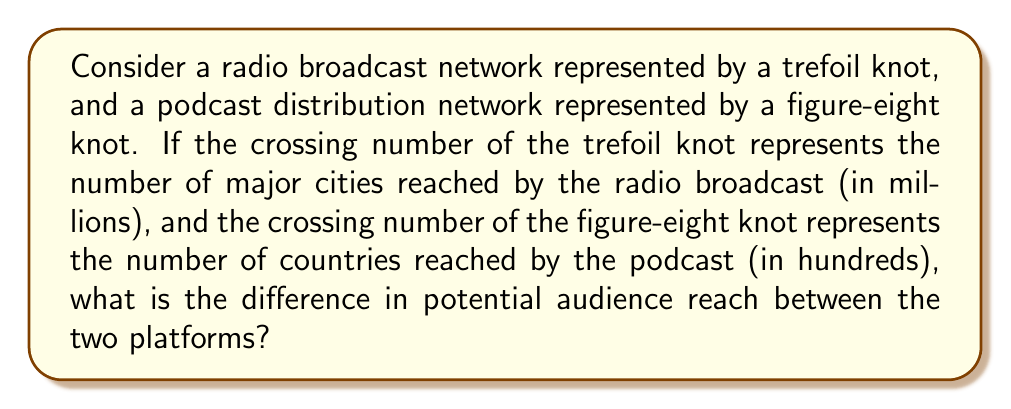Teach me how to tackle this problem. To solve this problem, we need to follow these steps:

1. Recall the crossing numbers for the trefoil and figure-eight knots:
   - The trefoil knot has a crossing number of 3.
   - The figure-eight knot has a crossing number of 4.

2. Interpret the crossing numbers according to the question:
   - For the radio broadcast (trefoil knot):
     3 crossing points = 3 million major cities reached
   - For the podcast distribution (figure-eight knot):
     4 crossing points = 4 hundred countries reached

3. Convert the units to be comparable:
   - Radio broadcast: 3 million cities
   - Podcast distribution: 400 countries

4. Estimate the potential audience reach:
   - Assume an average city population of 1 million
   - Assume an average country population of 10 million

5. Calculate the potential audience for each platform:
   - Radio broadcast: $3 \times 1,000,000 = 3,000,000$ people
   - Podcast distribution: $400 \times 10,000,000 = 4,000,000,000$ people

6. Find the difference in potential audience reach:
   $$4,000,000,000 - 3,000,000 = 3,997,000,000$$

Therefore, the difference in potential audience reach between the podcast distribution and the radio broadcast is 3,997,000,000 people, with the podcast having a significantly larger potential reach.
Answer: 3,997,000,000 people 